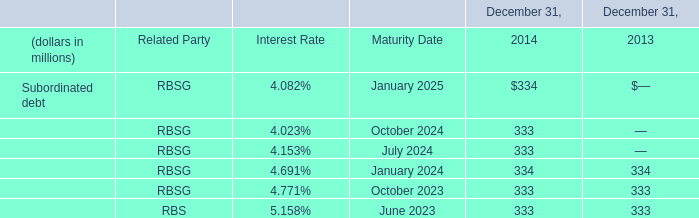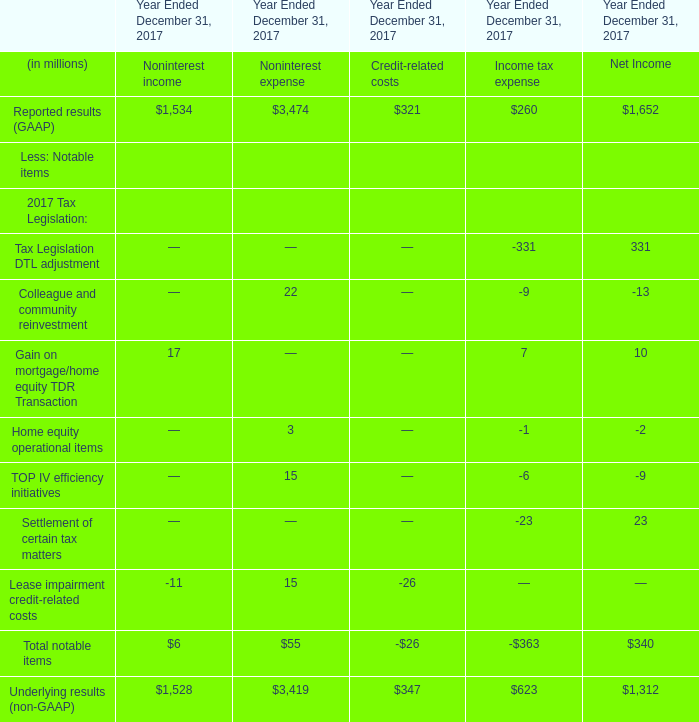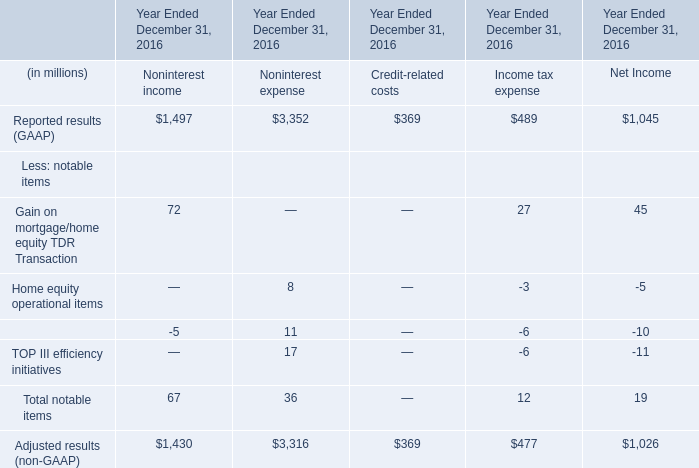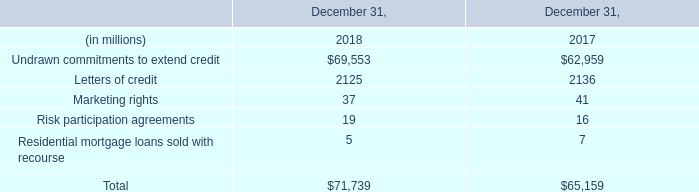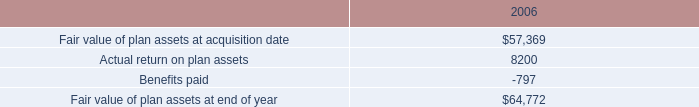In which section the sum of notable items in non-interest expense has the highest value? 
Answer: TOP III efficiency initiatives. 